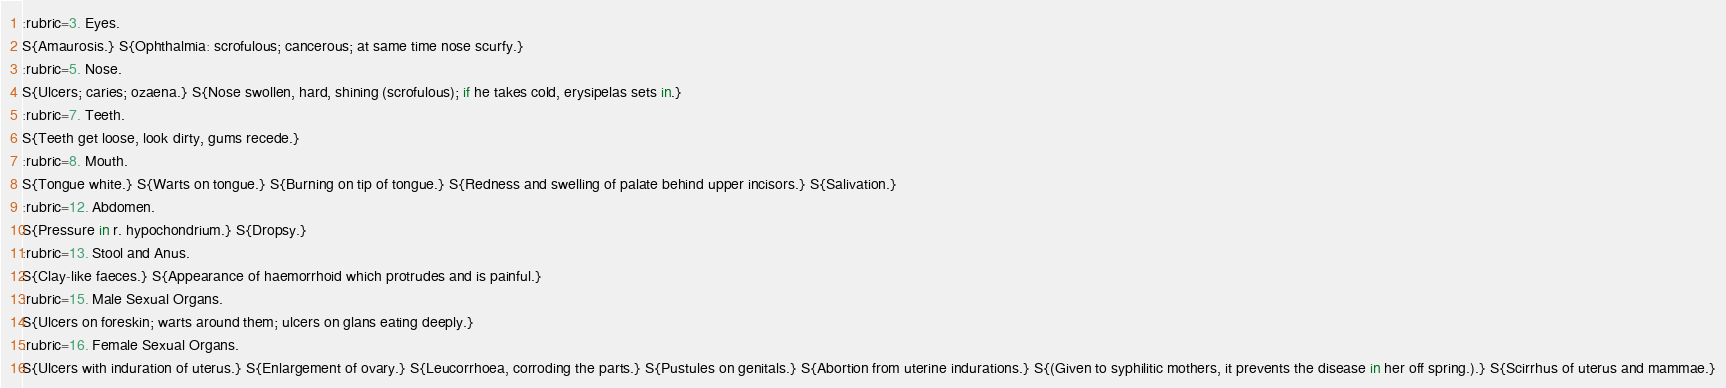<code> <loc_0><loc_0><loc_500><loc_500><_ObjectiveC_>:rubric=3. Eyes.
S{Amaurosis.} S{Ophthalmia: scrofulous; cancerous; at same time nose scurfy.}
:rubric=5. Nose.
S{Ulcers; caries; ozaena.} S{Nose swollen, hard, shining (scrofulous); if he takes cold, erysipelas sets in.}
:rubric=7. Teeth.
S{Teeth get loose, look dirty, gums recede.}
:rubric=8. Mouth.
S{Tongue white.} S{Warts on tongue.} S{Burning on tip of tongue.} S{Redness and swelling of palate behind upper incisors.} S{Salivation.}
:rubric=12. Abdomen.
S{Pressure in r. hypochondrium.} S{Dropsy.}
:rubric=13. Stool and Anus.
S{Clay-like faeces.} S{Appearance of haemorrhoid which protrudes and is painful.}
:rubric=15. Male Sexual Organs.
S{Ulcers on foreskin; warts around them; ulcers on glans eating deeply.}
:rubric=16. Female Sexual Organs.
S{Ulcers with induration of uterus.} S{Enlargement of ovary.} S{Leucorrhoea, corroding the parts.} S{Pustules on genitals.} S{Abortion from uterine indurations.} S{(Given to syphilitic mothers, it prevents the disease in her off spring.).} S{Scirrhus of uterus and mammae.}</code> 